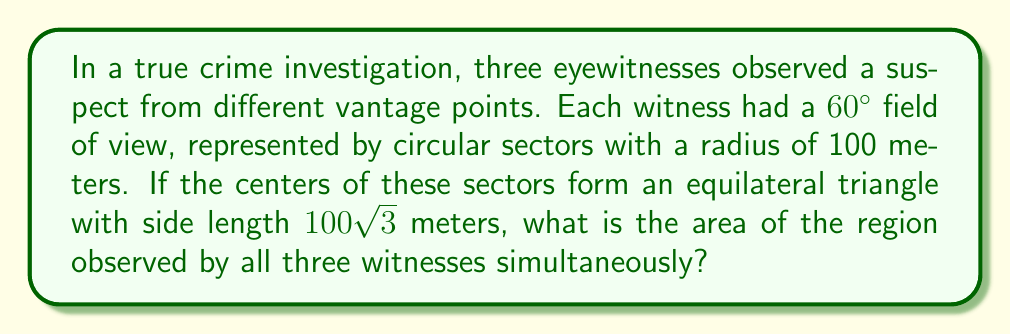Help me with this question. Let's approach this step-by-step:

1) First, we need to visualize the problem. We have three circular sectors, each with a central angle of 60° and a radius of 100 meters. The centers of these sectors form an equilateral triangle with side length 100√3 meters.

2) The area we're looking for is the intersection of all three sectors. This forms a curvilinear triangle in the center of our equilateral triangle.

3) To find this area, we can use the formula for the area of intersection of three circles:

   $$A = 3(R^2 \arccos(\frac{a}{2R}) - \frac{a}{4}\sqrt{4R^2-a^2})$$

   Where R is the radius of the circles and a is the side length of the equilateral triangle formed by their centers.

4) We're given that R = 100 and a = 100√3.

5) Substituting these values:

   $$A = 3(100^2 \arccos(\frac{100\sqrt{3}}{2(100)}) - \frac{100\sqrt{3}}{4}\sqrt{4(100)^2-(100\sqrt{3})^2})$$

6) Simplifying:

   $$A = 3(10000 \arccos(\frac{\sqrt{3}}{2}) - 25\sqrt{3}\sqrt{40000-30000})$$

   $$A = 30000 \arccos(\frac{\sqrt{3}}{2}) - 75\sqrt{3}\sqrt{10000}$$

   $$A = 30000 \arccos(\frac{\sqrt{3}}{2}) - 75000\sqrt{3}$$

7) The value of $\arccos(\frac{\sqrt{3}}{2})$ is $\frac{\pi}{6}$ or approximately 0.5236 radians.

8) Substituting this value:

   $$A = 30000 (\frac{\pi}{6}) - 75000\sqrt{3}$$

   $$A = 5000\pi - 75000\sqrt{3}$$

9) This evaluates to approximately 1006.45 square meters.
Answer: $5000\pi - 75000\sqrt{3}$ square meters 